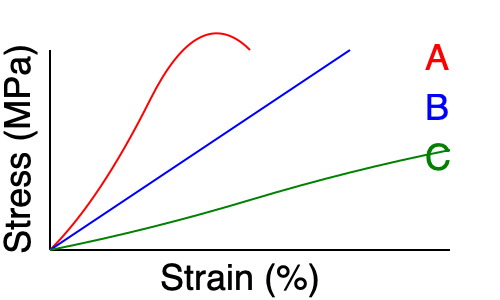Based on the stress-strain curves shown for three different polymer materials (A, B, and C), which material would be most suitable for an application requiring high elasticity and the ability to withstand large deformations without permanent damage? To determine the most suitable material for high elasticity and large deformations without permanent damage, we need to analyze the stress-strain curves:

1. Material A (red curve):
   - Shows a non-linear elastic behavior
   - Has a large strain range before failure
   - Exhibits a J-shaped curve typical of elastomers

2. Material B (blue curve):
   - Shows a linear elastic region followed by plastic deformation
   - Has a distinct yield point and undergoes permanent deformation

3. Material C (green curve):
   - Shows a gradual increase in stress with strain
   - Has a lower slope compared to A and B, indicating lower stiffness
   - Exhibits a large strain range before failure

Comparing these characteristics:

- Material A shows the highest elasticity, as indicated by its ability to reach high strains with a rapid increase in stress at larger strains. This behavior is typical of elastomers, which can undergo large deformations and return to their original shape.

- Material B is likely a more rigid polymer, showing less elasticity and undergoing permanent deformation after its yield point.

- Material C shows some elasticity but with lower stress resistance compared to A.

For an application requiring high elasticity and the ability to withstand large deformations without permanent damage, Material A is the most suitable choice. Its stress-strain curve is characteristic of elastomers, which are known for their ability to undergo large, reversible deformations.
Answer: Material A 